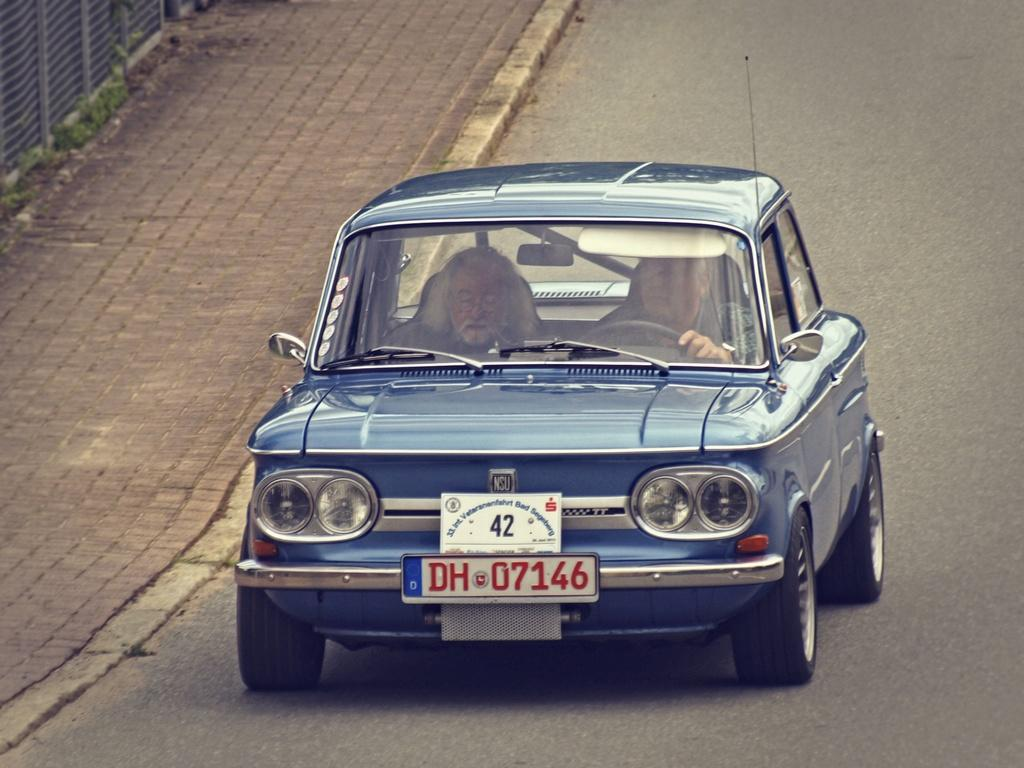What is happening in the foreground of the image? There is a man riding a car in the foreground of the image. How many people are in the car? There is another man in the car. Where is the car located? The car is on the road. What can be seen on the top left side of the image? There is a metal fence on the top left side of the image. 